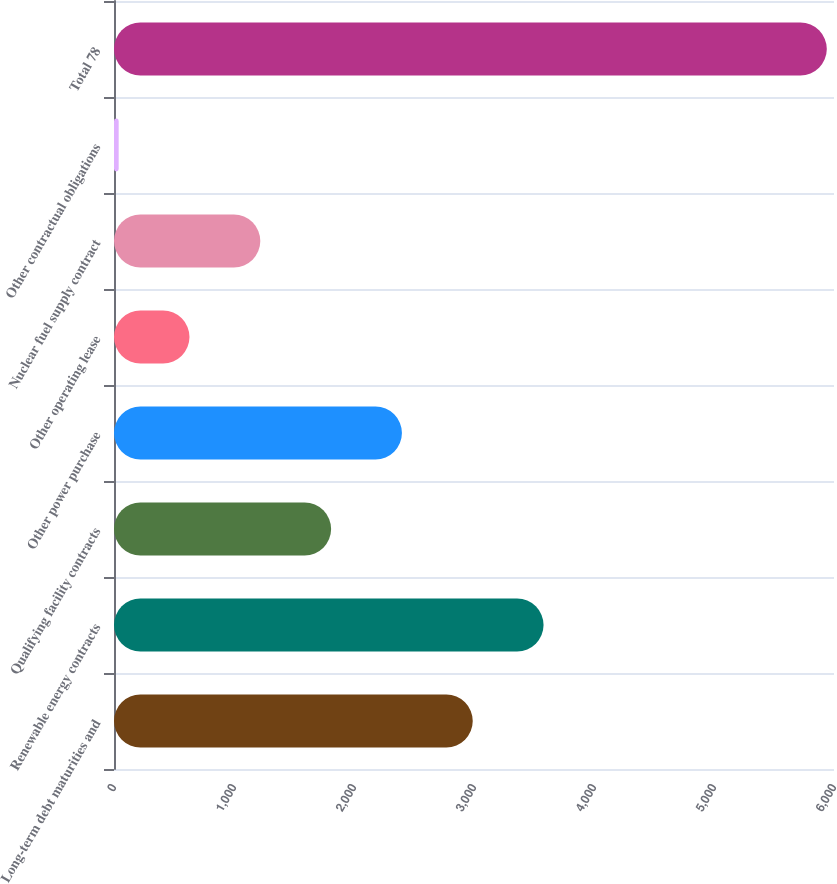<chart> <loc_0><loc_0><loc_500><loc_500><bar_chart><fcel>Long-term debt maturities and<fcel>Renewable energy contracts<fcel>Qualifying facility contracts<fcel>Other power purchase<fcel>Other operating lease<fcel>Nuclear fuel supply contract<fcel>Other contractual obligations<fcel>Total 78<nl><fcel>2989.5<fcel>3579.6<fcel>1809.3<fcel>2399.4<fcel>629.1<fcel>1219.2<fcel>39<fcel>5940<nl></chart> 